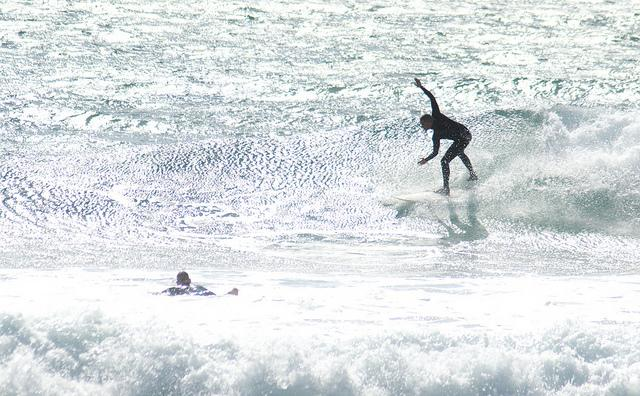Why is the man holding his arms out? Please explain your reasoning. to balance. Doing this type of extreme sport you need to stay on your board. 